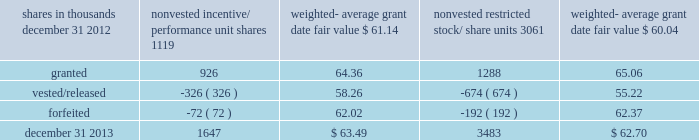To determine stock-based compensation expense , the grant date fair value is applied to the options granted with a reduction for estimated forfeitures .
We recognize compensation expense for stock options on a straight-line basis over the specified vesting period .
At december 31 , 2012 and 2011 , options for 12759000 and 12337000 shares of common stock were exercisable at a weighted-average price of $ 90.86 and $ 106.08 , respectively .
The total intrinsic value of options exercised during 2013 , 2012 and 2011 was $ 86 million , $ 37 million and $ 4 million , respectively .
The total tax benefit recognized related to compensation expense on all share-based payment arrangements during 2013 , 2012 and 2011 was approximately $ 56 million , $ 37 million and $ 38 million , respectively .
Cash received from option exercises under all incentive plans for 2013 , 2012 and 2011 was approximately $ 208 million , $ 118 million and $ 41 million , respectively .
The tax benefit realized from option exercises under all incentive plans for 2013 , 2012 and 2011 was approximately $ 31 million , $ 14 million and $ 1 million , respectively .
Shares of common stock available during the next year for the granting of options and other awards under the incentive plans were 24535159 at december 31 , 2013 .
Total shares of pnc common stock authorized for future issuance under equity compensation plans totaled 25712719 shares at december 31 , 2013 , which includes shares available for issuance under the incentive plans and the employee stock purchase plan ( espp ) as described below .
During 2013 , we issued approximately 2.6 million shares from treasury stock in connection with stock option exercise activity .
As with past exercise activity , we currently intend to utilize primarily treasury stock for any future stock option exercises .
Awards granted to non-employee directors in 2013 , 2012 and 2011 include 27076 , 25620 and 27090 deferred stock units , respectively , awarded under the outside directors deferred stock unit plan .
A deferred stock unit is a phantom share of our common stock , which is accounted for as a liability until such awards are paid to the participants in cash .
As there are no vesting or service requirements on these awards , total compensation expense is recognized in full for these awards on the date of grant .
Incentive/performance unit share awards and restricted stock/share unit awards the fair value of nonvested incentive/performance unit share awards and restricted stock/share unit awards is initially determined based on prices not less than the market value of our common stock on the date of grant .
The value of certain incentive/performance unit share awards is subsequently remeasured based on the achievement of one or more financial and other performance goals , generally over a three-year period .
The personnel and compensation committee ( 201cp&cc 201d ) of the board of directors approves the final award payout with respect to certain incentive/performance unit share awards .
Restricted stock/share unit awards have various vesting periods generally ranging from 3 years to 5 years .
Beginning in 2013 , we incorporated several enhanced risk- related performance changes to certain long-term incentive compensation programs .
In addition to achieving certain financial performance metrics on both an absolute basis and relative to our peers , final payout amounts will be subject to reduction if pnc fails to meet certain risk-related performance metrics as specified in the award agreement .
However , the p&cc has the discretion to waive any or all of this reduction under certain circumstances .
These awards have either a three- year or a four-year performance period and are payable in either stock or a combination of stock and cash .
Additionally , performance-based restricted share units were granted in 2013 to certain executives as part of annual bonus deferral criteria .
These units , payable solely in stock , vest ratably over a four-year period and contain the same risk- related discretionary criteria noted in the preceding paragraph .
The weighted-average grant date fair value of incentive/ performance unit share awards and restricted stock/unit awards granted in 2013 , 2012 and 2011 was $ 64.77 , $ 60.68 and $ 63.25 per share , respectively .
The total fair value of incentive/performance unit share and restricted stock/unit awards vested during 2013 , 2012 and 2011 was approximately $ 63 million , $ 55 million and $ 52 million , respectively .
We recognize compensation expense for such awards ratably over the corresponding vesting and/or performance periods for each type of program .
Table 124 : nonvested incentive/performance unit share awards and restricted stock/share unit awards 2013 rollforward shares in thousands nonvested incentive/ performance unit shares weighted- average grant date fair value nonvested restricted stock/ weighted- average grant date fair value .
The pnc financial services group , inc .
2013 form 10-k 187 .
For 2013 , what was the change in shares in thousands of nonvested incentive/ performance unit shares? 
Computations: (1647 - 1119)
Answer: 528.0. 